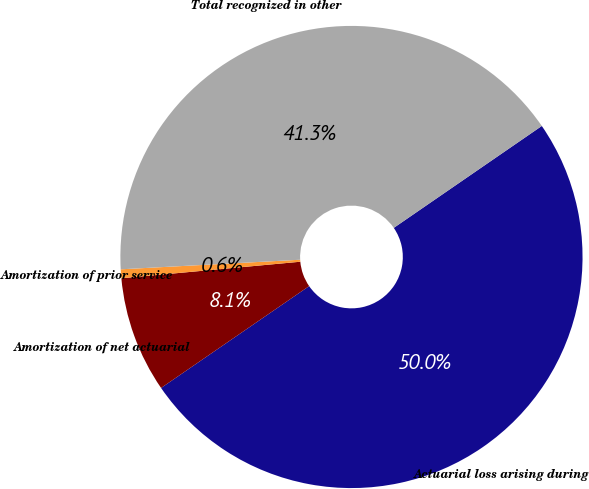<chart> <loc_0><loc_0><loc_500><loc_500><pie_chart><fcel>Actuarial loss arising during<fcel>Amortization of net actuarial<fcel>Amortization of prior service<fcel>Total recognized in other<nl><fcel>50.0%<fcel>8.12%<fcel>0.62%<fcel>41.25%<nl></chart> 